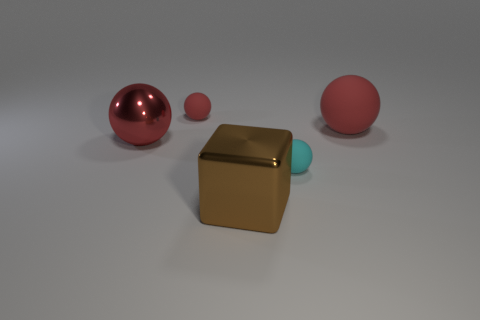Subtract all big red matte spheres. How many spheres are left? 3 Subtract all cyan balls. How many balls are left? 3 Subtract all green cylinders. How many red balls are left? 3 Subtract 2 balls. How many balls are left? 2 Add 4 big green cubes. How many objects exist? 9 Subtract all spheres. How many objects are left? 1 Add 3 tiny rubber balls. How many tiny rubber balls are left? 5 Add 1 large brown metallic cubes. How many large brown metallic cubes exist? 2 Subtract 0 brown cylinders. How many objects are left? 5 Subtract all purple spheres. Subtract all blue cylinders. How many spheres are left? 4 